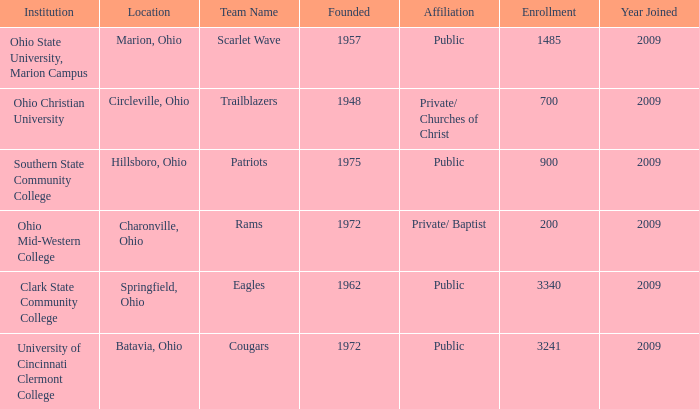What is the institution that was located is circleville, ohio? Ohio Christian University. 